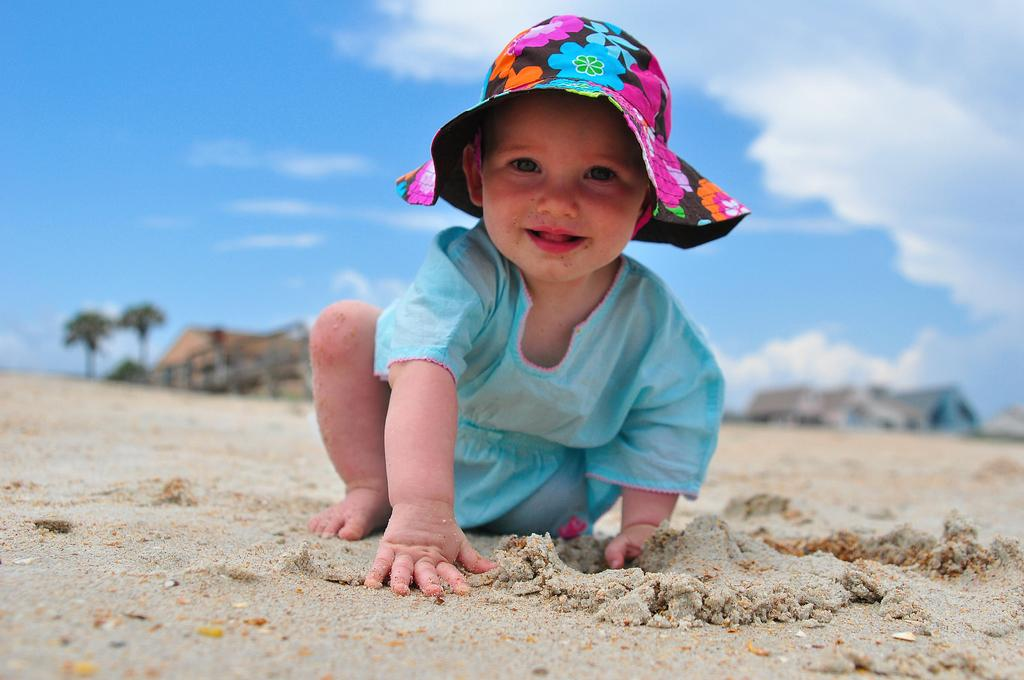What is the main subject of the image? There is a little cute baby in the image. Where is the baby located in the image? The baby is on the sand. What is the baby wearing in the image? The baby is wearing a blue color dress and a colorful hat. Where is the cellar located in the image? There is no cellar present in the image. Is there any poison visible in the image? There is no poison present in the image. 